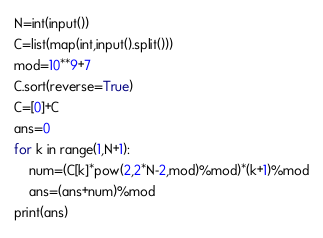Convert code to text. <code><loc_0><loc_0><loc_500><loc_500><_Python_>N=int(input())
C=list(map(int,input().split()))
mod=10**9+7
C.sort(reverse=True)
C=[0]+C
ans=0
for k in range(1,N+1):
    num=(C[k]*pow(2,2*N-2,mod)%mod)*(k+1)%mod
    ans=(ans+num)%mod 
print(ans)</code> 